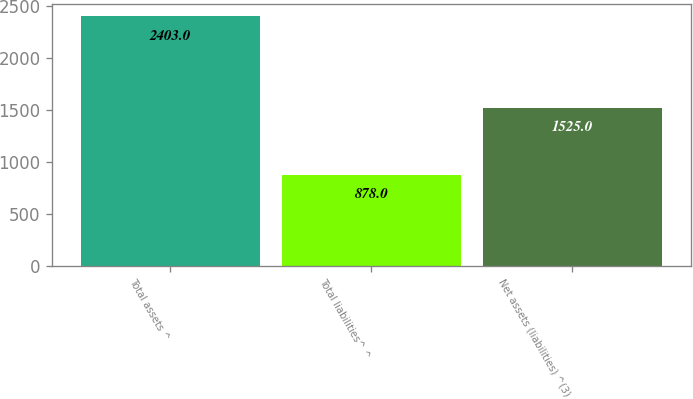Convert chart. <chart><loc_0><loc_0><loc_500><loc_500><bar_chart><fcel>Total assets ^<fcel>Total liabilities^ ^<fcel>Net assets (liabilities) ^(3)<nl><fcel>2403<fcel>878<fcel>1525<nl></chart> 